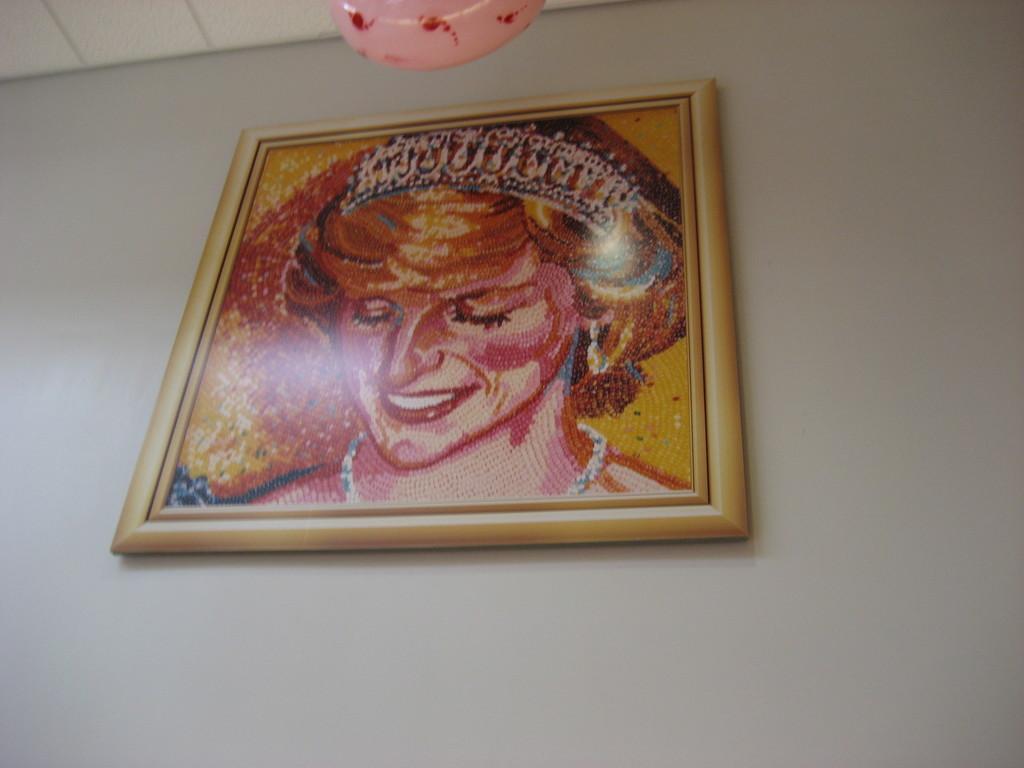How would you summarize this image in a sentence or two? In this image I can see a photo frame on the wall. It is looking like a painting. 